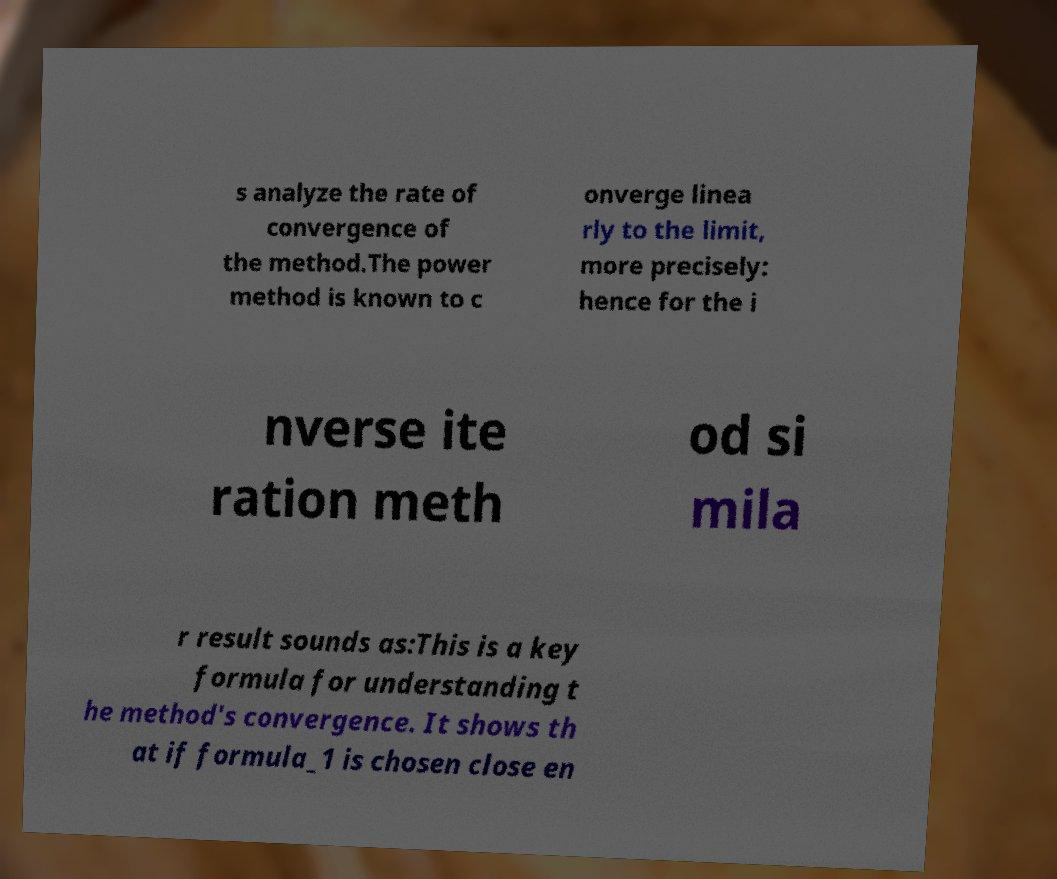There's text embedded in this image that I need extracted. Can you transcribe it verbatim? s analyze the rate of convergence of the method.The power method is known to c onverge linea rly to the limit, more precisely: hence for the i nverse ite ration meth od si mila r result sounds as:This is a key formula for understanding t he method's convergence. It shows th at if formula_1 is chosen close en 